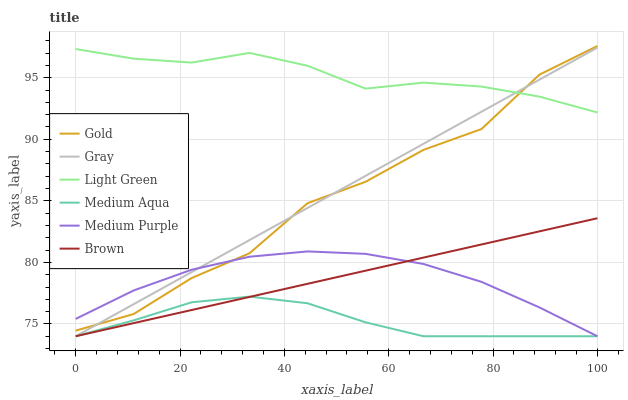Does Medium Aqua have the minimum area under the curve?
Answer yes or no. Yes. Does Light Green have the maximum area under the curve?
Answer yes or no. Yes. Does Gold have the minimum area under the curve?
Answer yes or no. No. Does Gold have the maximum area under the curve?
Answer yes or no. No. Is Gray the smoothest?
Answer yes or no. Yes. Is Gold the roughest?
Answer yes or no. Yes. Is Brown the smoothest?
Answer yes or no. No. Is Brown the roughest?
Answer yes or no. No. Does Gold have the lowest value?
Answer yes or no. No. Does Gold have the highest value?
Answer yes or no. Yes. Does Brown have the highest value?
Answer yes or no. No. Is Medium Purple less than Light Green?
Answer yes or no. Yes. Is Light Green greater than Medium Aqua?
Answer yes or no. Yes. Does Light Green intersect Gray?
Answer yes or no. Yes. Is Light Green less than Gray?
Answer yes or no. No. Is Light Green greater than Gray?
Answer yes or no. No. Does Medium Purple intersect Light Green?
Answer yes or no. No. 